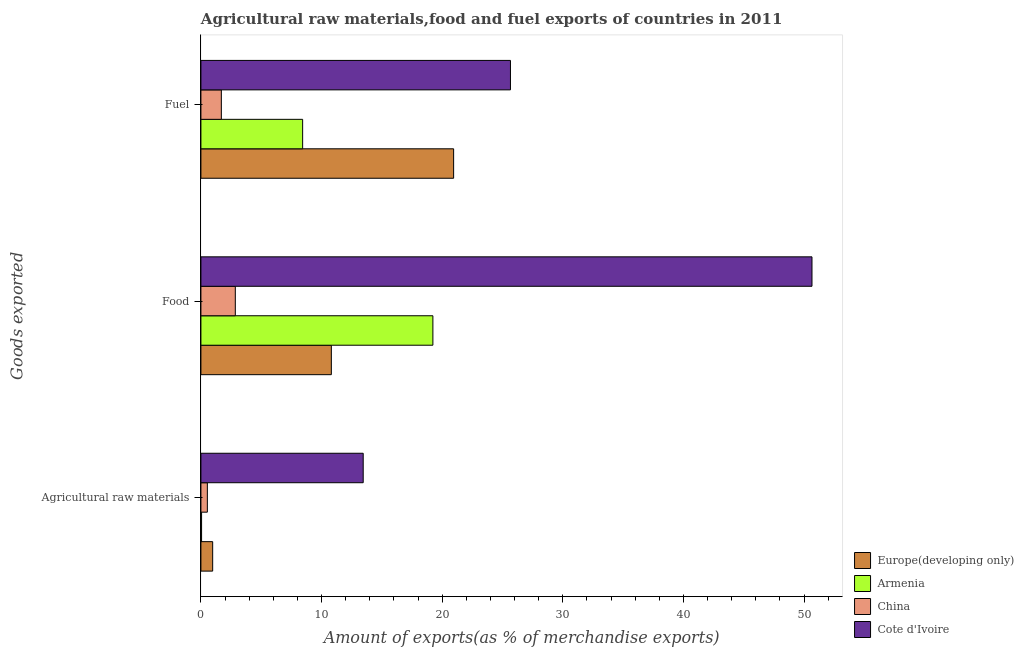How many different coloured bars are there?
Provide a succinct answer. 4. Are the number of bars per tick equal to the number of legend labels?
Give a very brief answer. Yes. Are the number of bars on each tick of the Y-axis equal?
Provide a short and direct response. Yes. What is the label of the 2nd group of bars from the top?
Provide a short and direct response. Food. What is the percentage of raw materials exports in China?
Give a very brief answer. 0.53. Across all countries, what is the maximum percentage of food exports?
Offer a very short reply. 50.66. Across all countries, what is the minimum percentage of fuel exports?
Ensure brevity in your answer.  1.69. In which country was the percentage of food exports maximum?
Your answer should be compact. Cote d'Ivoire. In which country was the percentage of raw materials exports minimum?
Make the answer very short. Armenia. What is the total percentage of fuel exports in the graph?
Provide a succinct answer. 56.74. What is the difference between the percentage of raw materials exports in Europe(developing only) and that in Armenia?
Your answer should be very brief. 0.92. What is the difference between the percentage of raw materials exports in Armenia and the percentage of food exports in China?
Your answer should be compact. -2.8. What is the average percentage of fuel exports per country?
Ensure brevity in your answer.  14.18. What is the difference between the percentage of fuel exports and percentage of food exports in China?
Your answer should be compact. -1.16. In how many countries, is the percentage of food exports greater than 38 %?
Offer a terse response. 1. What is the ratio of the percentage of raw materials exports in China to that in Cote d'Ivoire?
Keep it short and to the point. 0.04. Is the percentage of fuel exports in Cote d'Ivoire less than that in Armenia?
Give a very brief answer. No. What is the difference between the highest and the second highest percentage of raw materials exports?
Offer a terse response. 12.48. What is the difference between the highest and the lowest percentage of food exports?
Keep it short and to the point. 47.81. In how many countries, is the percentage of food exports greater than the average percentage of food exports taken over all countries?
Keep it short and to the point. 1. Is the sum of the percentage of food exports in China and Cote d'Ivoire greater than the maximum percentage of fuel exports across all countries?
Provide a short and direct response. Yes. What does the 1st bar from the top in Agricultural raw materials represents?
Your answer should be compact. Cote d'Ivoire. What is the difference between two consecutive major ticks on the X-axis?
Your answer should be very brief. 10. Are the values on the major ticks of X-axis written in scientific E-notation?
Offer a very short reply. No. Does the graph contain any zero values?
Provide a succinct answer. No. What is the title of the graph?
Ensure brevity in your answer.  Agricultural raw materials,food and fuel exports of countries in 2011. What is the label or title of the X-axis?
Your response must be concise. Amount of exports(as % of merchandise exports). What is the label or title of the Y-axis?
Your response must be concise. Goods exported. What is the Amount of exports(as % of merchandise exports) of Europe(developing only) in Agricultural raw materials?
Make the answer very short. 0.97. What is the Amount of exports(as % of merchandise exports) of Armenia in Agricultural raw materials?
Ensure brevity in your answer.  0.05. What is the Amount of exports(as % of merchandise exports) in China in Agricultural raw materials?
Offer a terse response. 0.53. What is the Amount of exports(as % of merchandise exports) of Cote d'Ivoire in Agricultural raw materials?
Your answer should be very brief. 13.45. What is the Amount of exports(as % of merchandise exports) of Europe(developing only) in Food?
Provide a succinct answer. 10.81. What is the Amount of exports(as % of merchandise exports) of Armenia in Food?
Ensure brevity in your answer.  19.23. What is the Amount of exports(as % of merchandise exports) in China in Food?
Ensure brevity in your answer.  2.85. What is the Amount of exports(as % of merchandise exports) of Cote d'Ivoire in Food?
Offer a very short reply. 50.66. What is the Amount of exports(as % of merchandise exports) in Europe(developing only) in Fuel?
Keep it short and to the point. 20.95. What is the Amount of exports(as % of merchandise exports) of Armenia in Fuel?
Your response must be concise. 8.43. What is the Amount of exports(as % of merchandise exports) of China in Fuel?
Provide a succinct answer. 1.69. What is the Amount of exports(as % of merchandise exports) of Cote d'Ivoire in Fuel?
Provide a short and direct response. 25.66. Across all Goods exported, what is the maximum Amount of exports(as % of merchandise exports) in Europe(developing only)?
Provide a short and direct response. 20.95. Across all Goods exported, what is the maximum Amount of exports(as % of merchandise exports) in Armenia?
Ensure brevity in your answer.  19.23. Across all Goods exported, what is the maximum Amount of exports(as % of merchandise exports) in China?
Make the answer very short. 2.85. Across all Goods exported, what is the maximum Amount of exports(as % of merchandise exports) of Cote d'Ivoire?
Your answer should be compact. 50.66. Across all Goods exported, what is the minimum Amount of exports(as % of merchandise exports) in Europe(developing only)?
Your answer should be very brief. 0.97. Across all Goods exported, what is the minimum Amount of exports(as % of merchandise exports) in Armenia?
Your response must be concise. 0.05. Across all Goods exported, what is the minimum Amount of exports(as % of merchandise exports) of China?
Keep it short and to the point. 0.53. Across all Goods exported, what is the minimum Amount of exports(as % of merchandise exports) in Cote d'Ivoire?
Offer a very short reply. 13.45. What is the total Amount of exports(as % of merchandise exports) in Europe(developing only) in the graph?
Provide a succinct answer. 32.73. What is the total Amount of exports(as % of merchandise exports) of Armenia in the graph?
Provide a succinct answer. 27.72. What is the total Amount of exports(as % of merchandise exports) of China in the graph?
Your answer should be very brief. 5.08. What is the total Amount of exports(as % of merchandise exports) of Cote d'Ivoire in the graph?
Provide a short and direct response. 89.77. What is the difference between the Amount of exports(as % of merchandise exports) in Europe(developing only) in Agricultural raw materials and that in Food?
Offer a terse response. -9.84. What is the difference between the Amount of exports(as % of merchandise exports) in Armenia in Agricultural raw materials and that in Food?
Provide a succinct answer. -19.18. What is the difference between the Amount of exports(as % of merchandise exports) in China in Agricultural raw materials and that in Food?
Offer a terse response. -2.32. What is the difference between the Amount of exports(as % of merchandise exports) of Cote d'Ivoire in Agricultural raw materials and that in Food?
Provide a short and direct response. -37.2. What is the difference between the Amount of exports(as % of merchandise exports) of Europe(developing only) in Agricultural raw materials and that in Fuel?
Make the answer very short. -19.97. What is the difference between the Amount of exports(as % of merchandise exports) of Armenia in Agricultural raw materials and that in Fuel?
Provide a short and direct response. -8.38. What is the difference between the Amount of exports(as % of merchandise exports) of China in Agricultural raw materials and that in Fuel?
Your answer should be compact. -1.16. What is the difference between the Amount of exports(as % of merchandise exports) in Cote d'Ivoire in Agricultural raw materials and that in Fuel?
Provide a succinct answer. -12.21. What is the difference between the Amount of exports(as % of merchandise exports) in Europe(developing only) in Food and that in Fuel?
Provide a succinct answer. -10.14. What is the difference between the Amount of exports(as % of merchandise exports) of Armenia in Food and that in Fuel?
Offer a terse response. 10.8. What is the difference between the Amount of exports(as % of merchandise exports) of China in Food and that in Fuel?
Provide a short and direct response. 1.16. What is the difference between the Amount of exports(as % of merchandise exports) of Cote d'Ivoire in Food and that in Fuel?
Offer a very short reply. 25. What is the difference between the Amount of exports(as % of merchandise exports) in Europe(developing only) in Agricultural raw materials and the Amount of exports(as % of merchandise exports) in Armenia in Food?
Your response must be concise. -18.26. What is the difference between the Amount of exports(as % of merchandise exports) in Europe(developing only) in Agricultural raw materials and the Amount of exports(as % of merchandise exports) in China in Food?
Give a very brief answer. -1.88. What is the difference between the Amount of exports(as % of merchandise exports) of Europe(developing only) in Agricultural raw materials and the Amount of exports(as % of merchandise exports) of Cote d'Ivoire in Food?
Make the answer very short. -49.68. What is the difference between the Amount of exports(as % of merchandise exports) in Armenia in Agricultural raw materials and the Amount of exports(as % of merchandise exports) in China in Food?
Keep it short and to the point. -2.8. What is the difference between the Amount of exports(as % of merchandise exports) in Armenia in Agricultural raw materials and the Amount of exports(as % of merchandise exports) in Cote d'Ivoire in Food?
Give a very brief answer. -50.6. What is the difference between the Amount of exports(as % of merchandise exports) in China in Agricultural raw materials and the Amount of exports(as % of merchandise exports) in Cote d'Ivoire in Food?
Your answer should be compact. -50.12. What is the difference between the Amount of exports(as % of merchandise exports) of Europe(developing only) in Agricultural raw materials and the Amount of exports(as % of merchandise exports) of Armenia in Fuel?
Offer a very short reply. -7.46. What is the difference between the Amount of exports(as % of merchandise exports) of Europe(developing only) in Agricultural raw materials and the Amount of exports(as % of merchandise exports) of China in Fuel?
Offer a very short reply. -0.72. What is the difference between the Amount of exports(as % of merchandise exports) of Europe(developing only) in Agricultural raw materials and the Amount of exports(as % of merchandise exports) of Cote d'Ivoire in Fuel?
Keep it short and to the point. -24.69. What is the difference between the Amount of exports(as % of merchandise exports) in Armenia in Agricultural raw materials and the Amount of exports(as % of merchandise exports) in China in Fuel?
Keep it short and to the point. -1.64. What is the difference between the Amount of exports(as % of merchandise exports) of Armenia in Agricultural raw materials and the Amount of exports(as % of merchandise exports) of Cote d'Ivoire in Fuel?
Offer a very short reply. -25.61. What is the difference between the Amount of exports(as % of merchandise exports) of China in Agricultural raw materials and the Amount of exports(as % of merchandise exports) of Cote d'Ivoire in Fuel?
Your response must be concise. -25.13. What is the difference between the Amount of exports(as % of merchandise exports) in Europe(developing only) in Food and the Amount of exports(as % of merchandise exports) in Armenia in Fuel?
Provide a short and direct response. 2.38. What is the difference between the Amount of exports(as % of merchandise exports) in Europe(developing only) in Food and the Amount of exports(as % of merchandise exports) in China in Fuel?
Offer a terse response. 9.12. What is the difference between the Amount of exports(as % of merchandise exports) of Europe(developing only) in Food and the Amount of exports(as % of merchandise exports) of Cote d'Ivoire in Fuel?
Offer a very short reply. -14.85. What is the difference between the Amount of exports(as % of merchandise exports) in Armenia in Food and the Amount of exports(as % of merchandise exports) in China in Fuel?
Your answer should be very brief. 17.54. What is the difference between the Amount of exports(as % of merchandise exports) in Armenia in Food and the Amount of exports(as % of merchandise exports) in Cote d'Ivoire in Fuel?
Provide a succinct answer. -6.43. What is the difference between the Amount of exports(as % of merchandise exports) of China in Food and the Amount of exports(as % of merchandise exports) of Cote d'Ivoire in Fuel?
Your response must be concise. -22.81. What is the average Amount of exports(as % of merchandise exports) of Europe(developing only) per Goods exported?
Provide a succinct answer. 10.91. What is the average Amount of exports(as % of merchandise exports) of Armenia per Goods exported?
Your answer should be very brief. 9.24. What is the average Amount of exports(as % of merchandise exports) in China per Goods exported?
Make the answer very short. 1.69. What is the average Amount of exports(as % of merchandise exports) in Cote d'Ivoire per Goods exported?
Provide a short and direct response. 29.92. What is the difference between the Amount of exports(as % of merchandise exports) of Europe(developing only) and Amount of exports(as % of merchandise exports) of Armenia in Agricultural raw materials?
Offer a very short reply. 0.92. What is the difference between the Amount of exports(as % of merchandise exports) in Europe(developing only) and Amount of exports(as % of merchandise exports) in China in Agricultural raw materials?
Offer a very short reply. 0.44. What is the difference between the Amount of exports(as % of merchandise exports) in Europe(developing only) and Amount of exports(as % of merchandise exports) in Cote d'Ivoire in Agricultural raw materials?
Make the answer very short. -12.48. What is the difference between the Amount of exports(as % of merchandise exports) of Armenia and Amount of exports(as % of merchandise exports) of China in Agricultural raw materials?
Provide a short and direct response. -0.48. What is the difference between the Amount of exports(as % of merchandise exports) in Armenia and Amount of exports(as % of merchandise exports) in Cote d'Ivoire in Agricultural raw materials?
Keep it short and to the point. -13.4. What is the difference between the Amount of exports(as % of merchandise exports) of China and Amount of exports(as % of merchandise exports) of Cote d'Ivoire in Agricultural raw materials?
Offer a very short reply. -12.92. What is the difference between the Amount of exports(as % of merchandise exports) of Europe(developing only) and Amount of exports(as % of merchandise exports) of Armenia in Food?
Your answer should be compact. -8.42. What is the difference between the Amount of exports(as % of merchandise exports) in Europe(developing only) and Amount of exports(as % of merchandise exports) in China in Food?
Provide a succinct answer. 7.96. What is the difference between the Amount of exports(as % of merchandise exports) of Europe(developing only) and Amount of exports(as % of merchandise exports) of Cote d'Ivoire in Food?
Offer a terse response. -39.85. What is the difference between the Amount of exports(as % of merchandise exports) in Armenia and Amount of exports(as % of merchandise exports) in China in Food?
Provide a succinct answer. 16.38. What is the difference between the Amount of exports(as % of merchandise exports) of Armenia and Amount of exports(as % of merchandise exports) of Cote d'Ivoire in Food?
Your answer should be very brief. -31.43. What is the difference between the Amount of exports(as % of merchandise exports) in China and Amount of exports(as % of merchandise exports) in Cote d'Ivoire in Food?
Provide a succinct answer. -47.81. What is the difference between the Amount of exports(as % of merchandise exports) in Europe(developing only) and Amount of exports(as % of merchandise exports) in Armenia in Fuel?
Provide a short and direct response. 12.52. What is the difference between the Amount of exports(as % of merchandise exports) in Europe(developing only) and Amount of exports(as % of merchandise exports) in China in Fuel?
Provide a succinct answer. 19.26. What is the difference between the Amount of exports(as % of merchandise exports) of Europe(developing only) and Amount of exports(as % of merchandise exports) of Cote d'Ivoire in Fuel?
Give a very brief answer. -4.71. What is the difference between the Amount of exports(as % of merchandise exports) in Armenia and Amount of exports(as % of merchandise exports) in China in Fuel?
Provide a short and direct response. 6.74. What is the difference between the Amount of exports(as % of merchandise exports) in Armenia and Amount of exports(as % of merchandise exports) in Cote d'Ivoire in Fuel?
Make the answer very short. -17.23. What is the difference between the Amount of exports(as % of merchandise exports) in China and Amount of exports(as % of merchandise exports) in Cote d'Ivoire in Fuel?
Your response must be concise. -23.97. What is the ratio of the Amount of exports(as % of merchandise exports) of Europe(developing only) in Agricultural raw materials to that in Food?
Offer a terse response. 0.09. What is the ratio of the Amount of exports(as % of merchandise exports) of Armenia in Agricultural raw materials to that in Food?
Ensure brevity in your answer.  0. What is the ratio of the Amount of exports(as % of merchandise exports) of China in Agricultural raw materials to that in Food?
Keep it short and to the point. 0.19. What is the ratio of the Amount of exports(as % of merchandise exports) of Cote d'Ivoire in Agricultural raw materials to that in Food?
Ensure brevity in your answer.  0.27. What is the ratio of the Amount of exports(as % of merchandise exports) of Europe(developing only) in Agricultural raw materials to that in Fuel?
Give a very brief answer. 0.05. What is the ratio of the Amount of exports(as % of merchandise exports) of Armenia in Agricultural raw materials to that in Fuel?
Keep it short and to the point. 0.01. What is the ratio of the Amount of exports(as % of merchandise exports) of China in Agricultural raw materials to that in Fuel?
Your answer should be compact. 0.32. What is the ratio of the Amount of exports(as % of merchandise exports) of Cote d'Ivoire in Agricultural raw materials to that in Fuel?
Provide a short and direct response. 0.52. What is the ratio of the Amount of exports(as % of merchandise exports) of Europe(developing only) in Food to that in Fuel?
Make the answer very short. 0.52. What is the ratio of the Amount of exports(as % of merchandise exports) of Armenia in Food to that in Fuel?
Your response must be concise. 2.28. What is the ratio of the Amount of exports(as % of merchandise exports) of China in Food to that in Fuel?
Keep it short and to the point. 1.68. What is the ratio of the Amount of exports(as % of merchandise exports) in Cote d'Ivoire in Food to that in Fuel?
Provide a short and direct response. 1.97. What is the difference between the highest and the second highest Amount of exports(as % of merchandise exports) of Europe(developing only)?
Offer a very short reply. 10.14. What is the difference between the highest and the second highest Amount of exports(as % of merchandise exports) of Armenia?
Ensure brevity in your answer.  10.8. What is the difference between the highest and the second highest Amount of exports(as % of merchandise exports) in China?
Keep it short and to the point. 1.16. What is the difference between the highest and the second highest Amount of exports(as % of merchandise exports) of Cote d'Ivoire?
Your answer should be very brief. 25. What is the difference between the highest and the lowest Amount of exports(as % of merchandise exports) of Europe(developing only)?
Offer a terse response. 19.97. What is the difference between the highest and the lowest Amount of exports(as % of merchandise exports) of Armenia?
Ensure brevity in your answer.  19.18. What is the difference between the highest and the lowest Amount of exports(as % of merchandise exports) of China?
Make the answer very short. 2.32. What is the difference between the highest and the lowest Amount of exports(as % of merchandise exports) of Cote d'Ivoire?
Offer a very short reply. 37.2. 